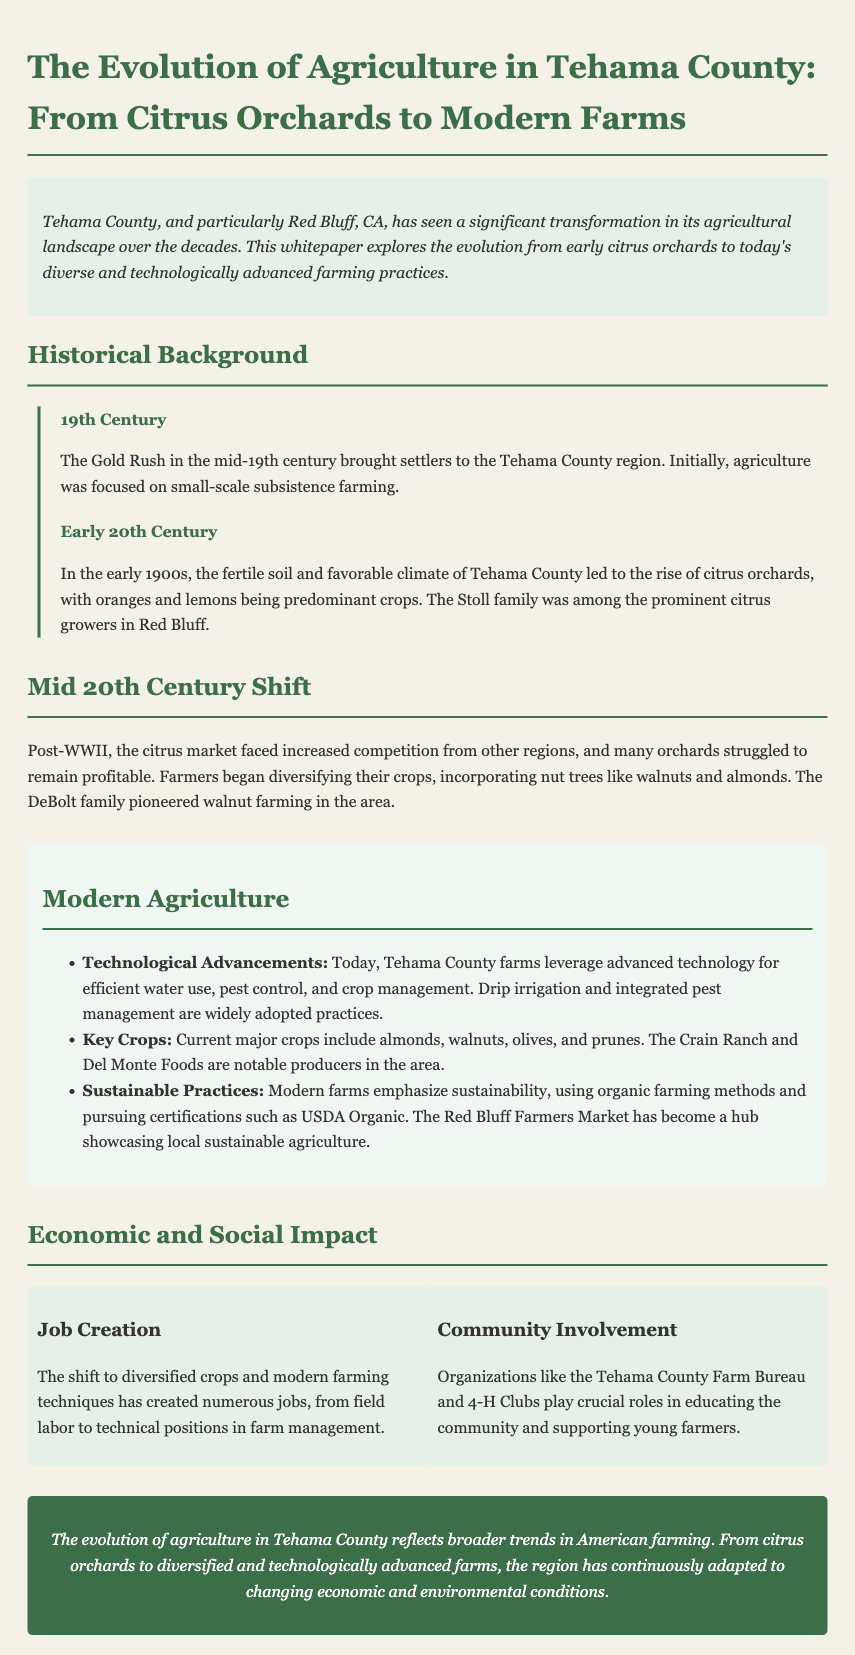What brought settlers to Tehama County? The document states that the Gold Rush in the mid-19th century brought settlers to the Tehama County region.
Answer: Gold Rush When did citrus orchards begin to rise in Tehama County? According to the document, the early 1900s saw the rise of citrus orchards in Tehama County.
Answer: Early 1900s Who was a prominent citrus grower in Red Bluff? The whitepaper mentions that the Stoll family was among the prominent citrus growers in Red Bluff.
Answer: Stoll family What crop did the DeBolt family pioneer in Tehama County? The document states that the DeBolt family pioneered walnut farming in the area.
Answer: Walnut What are two key crops mentioned in modern agriculture in Tehama County? The key crops listed in the document are almonds and walnuts.
Answer: Almonds, walnuts What type of farming practices do modern farms emphasize? Modern farms in Tehama County emphasize sustainability, as stated in the document.
Answer: Sustainability Which organizations support young farmers in Tehama County? The Tehama County Farm Bureau and 4-H Clubs are mentioned as organizations supporting young farmers.
Answer: Tehama County Farm Bureau, 4-H Clubs What is a notable hub for showcasing local sustainable agriculture? The Red Bluff Farmers Market is identified as a hub for showcasing local sustainable agriculture.
Answer: Red Bluff Farmers Market 